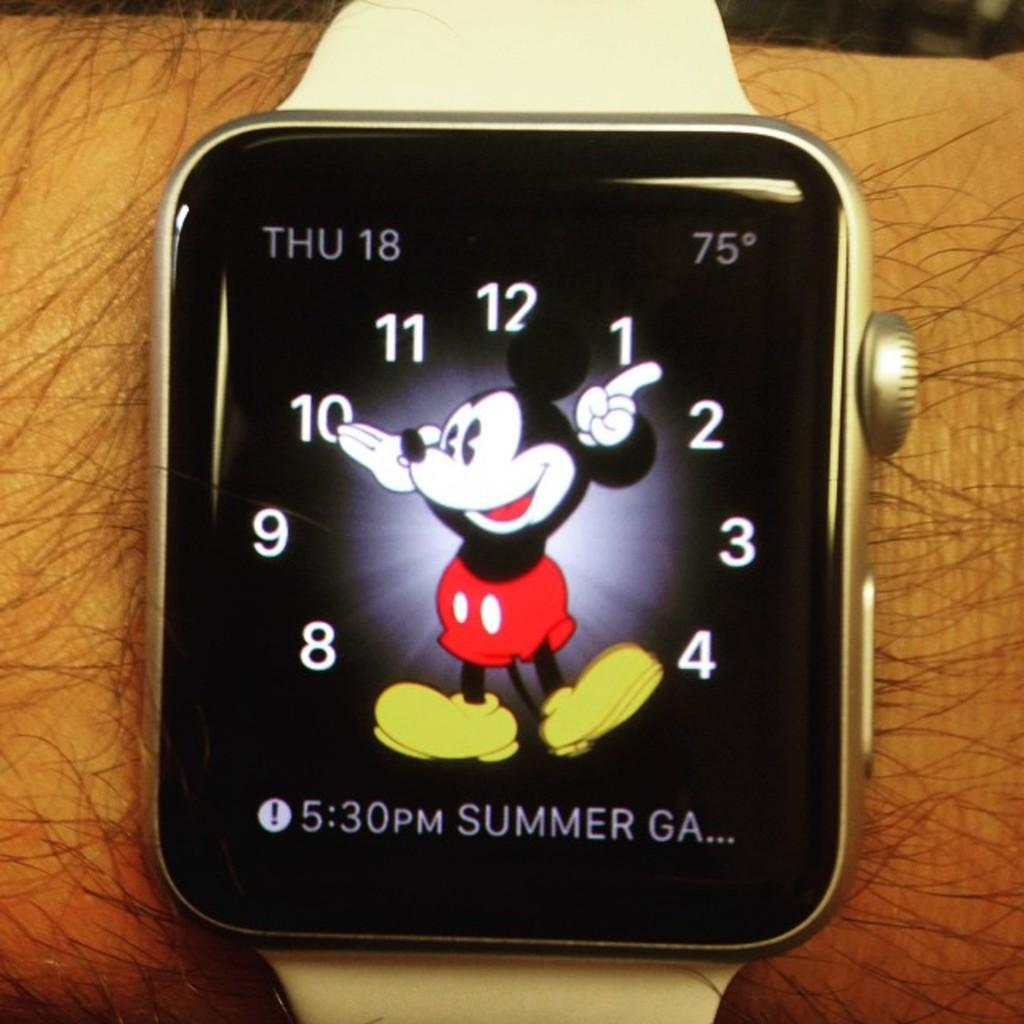<image>
Relay a brief, clear account of the picture shown. A man is wearing a watch with Mickey Mouse on it and the word summer. 